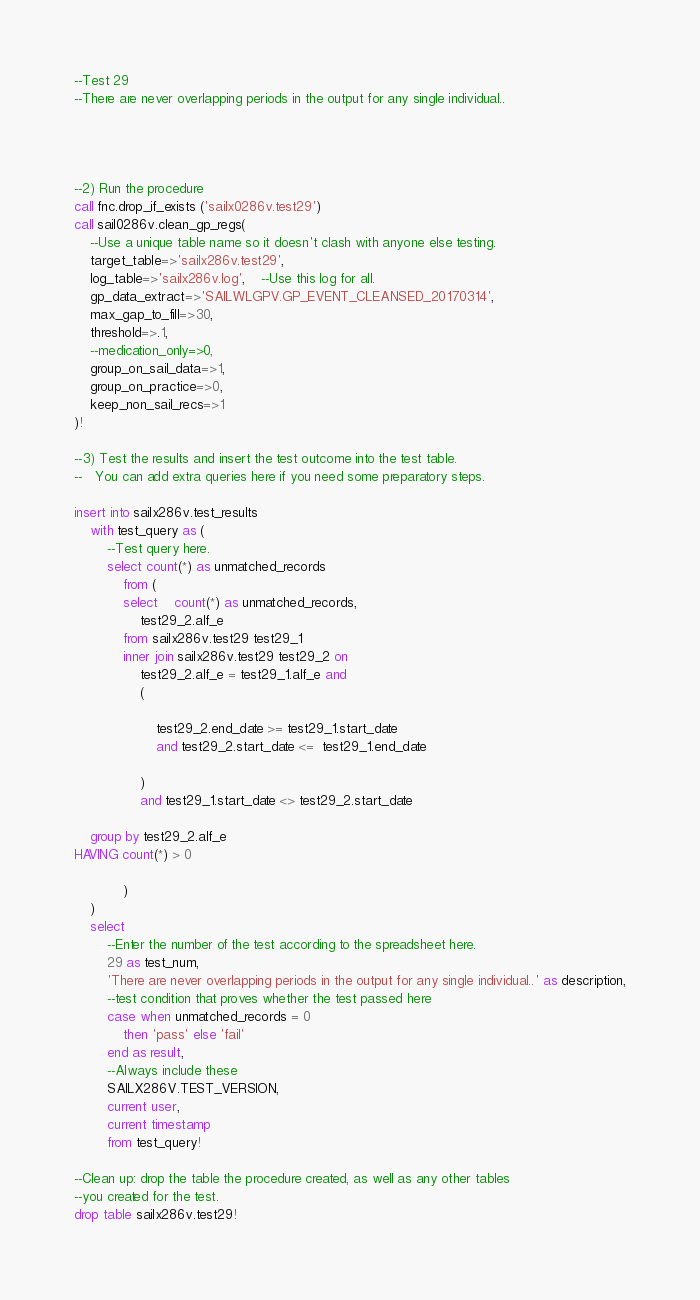Convert code to text. <code><loc_0><loc_0><loc_500><loc_500><_SQL_>--Test 29
--There are never overlapping periods in the output for any single individual..




--2) Run the procedure
call fnc.drop_if_exists ('sailx0286v.test29')
call sail0286v.clean_gp_regs(
	--Use a unique table name so it doesn't clash with anyone else testing.
	target_table=>'sailx286v.test29',
	log_table=>'sailx286v.log', 	--Use this log for all.
	gp_data_extract=>'SAILWLGPV.GP_EVENT_CLEANSED_20170314',
	max_gap_to_fill=>30, 
	threshold=>.1,
	--medication_only=>0,
	group_on_sail_data=>1,
	group_on_practice=>0,
	keep_non_sail_recs=>1
)!

--3) Test the results and insert the test outcome into the test table.
--   You can add extra queries here if you need some preparatory steps.

insert into sailx286v.test_results
	with test_query as (
		--Test query here.
		select count(*) as unmatched_records 
 			from (
 			select 	count(*) as unmatched_records, 
				test29_2.alf_e  
 			from sailx286v.test29 test29_1 				
			inner join sailx286v.test29 test29_2 on
				test29_2.alf_e = test29_1.alf_e and
				(
				
					test29_2.end_date >= test29_1.start_date
					and test29_2.start_date <=  test29_1.end_date 
					 
				)  
				and test29_1.start_date <> test29_2.start_date
	
	group by test29_2.alf_e  
HAVING count(*) > 0
 			
 			)
	)
	select 
		--Enter the number of the test according to the spreadsheet here.
		29 as test_num,
		'There are never overlapping periods in the output for any single individual..' as description,
		--test condition that proves whether the test passed here
		case when unmatched_records = 0 	
			then 'pass' else 'fail'
		end as result,
		--Always include these
		SAILX286V.TEST_VERSION,
		current user,
		current timestamp
		from test_query!

--Clean up: drop the table the procedure created, as well as any other tables
--you created for the test.
drop table sailx286v.test29!

</code> 